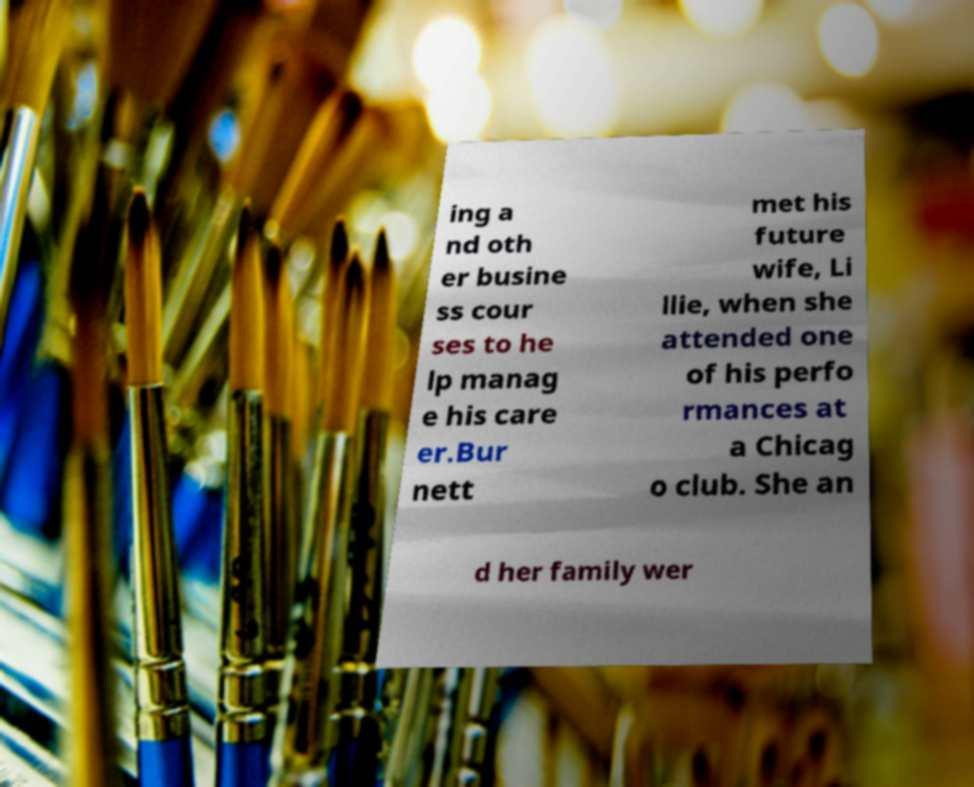What messages or text are displayed in this image? I need them in a readable, typed format. ing a nd oth er busine ss cour ses to he lp manag e his care er.Bur nett met his future wife, Li llie, when she attended one of his perfo rmances at a Chicag o club. She an d her family wer 